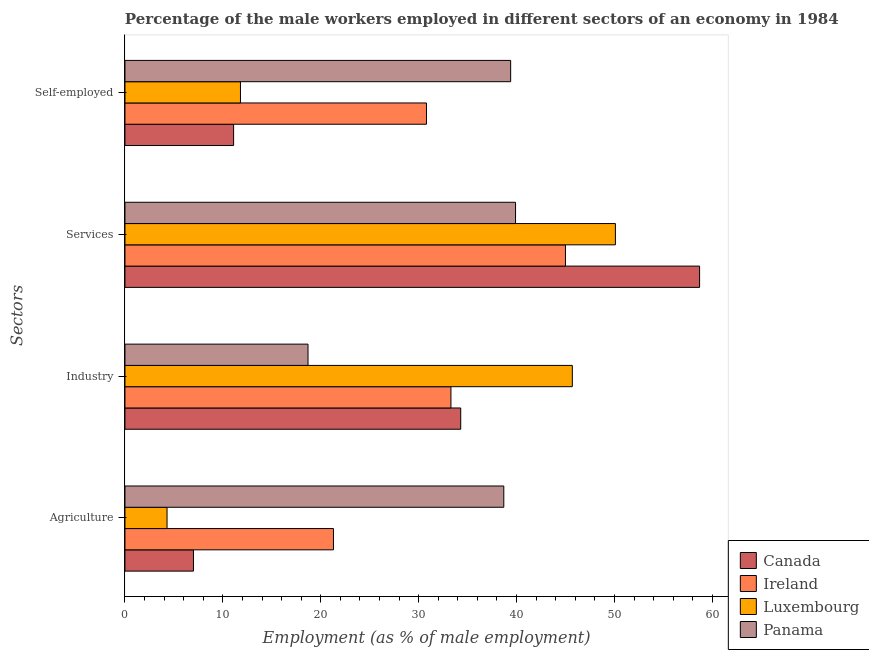How many groups of bars are there?
Give a very brief answer. 4. Are the number of bars per tick equal to the number of legend labels?
Provide a succinct answer. Yes. Are the number of bars on each tick of the Y-axis equal?
Offer a terse response. Yes. How many bars are there on the 4th tick from the top?
Make the answer very short. 4. What is the label of the 2nd group of bars from the top?
Offer a very short reply. Services. What is the percentage of male workers in industry in Ireland?
Your response must be concise. 33.3. Across all countries, what is the maximum percentage of male workers in services?
Ensure brevity in your answer.  58.7. Across all countries, what is the minimum percentage of self employed male workers?
Provide a short and direct response. 11.1. In which country was the percentage of male workers in services maximum?
Provide a short and direct response. Canada. In which country was the percentage of male workers in industry minimum?
Provide a short and direct response. Panama. What is the total percentage of male workers in services in the graph?
Provide a succinct answer. 193.7. What is the difference between the percentage of male workers in services in Luxembourg and that in Canada?
Provide a succinct answer. -8.6. What is the difference between the percentage of male workers in industry in Canada and the percentage of male workers in services in Luxembourg?
Provide a succinct answer. -15.8. What is the average percentage of male workers in services per country?
Offer a very short reply. 48.43. What is the difference between the percentage of male workers in industry and percentage of self employed male workers in Ireland?
Ensure brevity in your answer.  2.5. What is the ratio of the percentage of male workers in services in Canada to that in Panama?
Give a very brief answer. 1.47. Is the percentage of male workers in industry in Canada less than that in Panama?
Your response must be concise. No. Is the difference between the percentage of male workers in industry in Luxembourg and Ireland greater than the difference between the percentage of male workers in agriculture in Luxembourg and Ireland?
Your answer should be compact. Yes. What is the difference between the highest and the second highest percentage of male workers in agriculture?
Ensure brevity in your answer.  17.4. What is the difference between the highest and the lowest percentage of self employed male workers?
Offer a very short reply. 28.3. In how many countries, is the percentage of male workers in industry greater than the average percentage of male workers in industry taken over all countries?
Your answer should be compact. 3. Is the sum of the percentage of male workers in industry in Luxembourg and Canada greater than the maximum percentage of self employed male workers across all countries?
Make the answer very short. Yes. What does the 1st bar from the top in Agriculture represents?
Give a very brief answer. Panama. What does the 4th bar from the bottom in Agriculture represents?
Your answer should be compact. Panama. How many bars are there?
Give a very brief answer. 16. Are all the bars in the graph horizontal?
Provide a short and direct response. Yes. Are the values on the major ticks of X-axis written in scientific E-notation?
Offer a very short reply. No. Does the graph contain grids?
Give a very brief answer. No. Where does the legend appear in the graph?
Offer a very short reply. Bottom right. How many legend labels are there?
Offer a terse response. 4. How are the legend labels stacked?
Provide a short and direct response. Vertical. What is the title of the graph?
Your answer should be compact. Percentage of the male workers employed in different sectors of an economy in 1984. What is the label or title of the X-axis?
Keep it short and to the point. Employment (as % of male employment). What is the label or title of the Y-axis?
Your answer should be compact. Sectors. What is the Employment (as % of male employment) of Ireland in Agriculture?
Make the answer very short. 21.3. What is the Employment (as % of male employment) in Luxembourg in Agriculture?
Your answer should be very brief. 4.3. What is the Employment (as % of male employment) of Panama in Agriculture?
Keep it short and to the point. 38.7. What is the Employment (as % of male employment) of Canada in Industry?
Provide a succinct answer. 34.3. What is the Employment (as % of male employment) in Ireland in Industry?
Give a very brief answer. 33.3. What is the Employment (as % of male employment) of Luxembourg in Industry?
Ensure brevity in your answer.  45.7. What is the Employment (as % of male employment) in Panama in Industry?
Ensure brevity in your answer.  18.7. What is the Employment (as % of male employment) of Canada in Services?
Offer a very short reply. 58.7. What is the Employment (as % of male employment) in Luxembourg in Services?
Make the answer very short. 50.1. What is the Employment (as % of male employment) of Panama in Services?
Make the answer very short. 39.9. What is the Employment (as % of male employment) of Canada in Self-employed?
Your response must be concise. 11.1. What is the Employment (as % of male employment) in Ireland in Self-employed?
Your answer should be compact. 30.8. What is the Employment (as % of male employment) of Luxembourg in Self-employed?
Your answer should be very brief. 11.8. What is the Employment (as % of male employment) of Panama in Self-employed?
Your response must be concise. 39.4. Across all Sectors, what is the maximum Employment (as % of male employment) of Canada?
Offer a very short reply. 58.7. Across all Sectors, what is the maximum Employment (as % of male employment) of Ireland?
Keep it short and to the point. 45. Across all Sectors, what is the maximum Employment (as % of male employment) of Luxembourg?
Offer a very short reply. 50.1. Across all Sectors, what is the maximum Employment (as % of male employment) in Panama?
Your answer should be very brief. 39.9. Across all Sectors, what is the minimum Employment (as % of male employment) in Canada?
Make the answer very short. 7. Across all Sectors, what is the minimum Employment (as % of male employment) in Ireland?
Offer a terse response. 21.3. Across all Sectors, what is the minimum Employment (as % of male employment) of Luxembourg?
Your answer should be compact. 4.3. Across all Sectors, what is the minimum Employment (as % of male employment) in Panama?
Offer a very short reply. 18.7. What is the total Employment (as % of male employment) of Canada in the graph?
Provide a succinct answer. 111.1. What is the total Employment (as % of male employment) in Ireland in the graph?
Ensure brevity in your answer.  130.4. What is the total Employment (as % of male employment) in Luxembourg in the graph?
Your answer should be compact. 111.9. What is the total Employment (as % of male employment) of Panama in the graph?
Ensure brevity in your answer.  136.7. What is the difference between the Employment (as % of male employment) of Canada in Agriculture and that in Industry?
Offer a very short reply. -27.3. What is the difference between the Employment (as % of male employment) of Ireland in Agriculture and that in Industry?
Offer a terse response. -12. What is the difference between the Employment (as % of male employment) of Luxembourg in Agriculture and that in Industry?
Provide a succinct answer. -41.4. What is the difference between the Employment (as % of male employment) in Panama in Agriculture and that in Industry?
Provide a short and direct response. 20. What is the difference between the Employment (as % of male employment) of Canada in Agriculture and that in Services?
Your answer should be very brief. -51.7. What is the difference between the Employment (as % of male employment) of Ireland in Agriculture and that in Services?
Your answer should be very brief. -23.7. What is the difference between the Employment (as % of male employment) in Luxembourg in Agriculture and that in Services?
Your response must be concise. -45.8. What is the difference between the Employment (as % of male employment) in Canada in Agriculture and that in Self-employed?
Provide a short and direct response. -4.1. What is the difference between the Employment (as % of male employment) in Luxembourg in Agriculture and that in Self-employed?
Make the answer very short. -7.5. What is the difference between the Employment (as % of male employment) of Panama in Agriculture and that in Self-employed?
Your response must be concise. -0.7. What is the difference between the Employment (as % of male employment) of Canada in Industry and that in Services?
Provide a succinct answer. -24.4. What is the difference between the Employment (as % of male employment) of Panama in Industry and that in Services?
Provide a short and direct response. -21.2. What is the difference between the Employment (as % of male employment) in Canada in Industry and that in Self-employed?
Offer a terse response. 23.2. What is the difference between the Employment (as % of male employment) in Luxembourg in Industry and that in Self-employed?
Your response must be concise. 33.9. What is the difference between the Employment (as % of male employment) of Panama in Industry and that in Self-employed?
Give a very brief answer. -20.7. What is the difference between the Employment (as % of male employment) of Canada in Services and that in Self-employed?
Your response must be concise. 47.6. What is the difference between the Employment (as % of male employment) in Luxembourg in Services and that in Self-employed?
Make the answer very short. 38.3. What is the difference between the Employment (as % of male employment) in Panama in Services and that in Self-employed?
Provide a succinct answer. 0.5. What is the difference between the Employment (as % of male employment) of Canada in Agriculture and the Employment (as % of male employment) of Ireland in Industry?
Your answer should be very brief. -26.3. What is the difference between the Employment (as % of male employment) in Canada in Agriculture and the Employment (as % of male employment) in Luxembourg in Industry?
Give a very brief answer. -38.7. What is the difference between the Employment (as % of male employment) in Canada in Agriculture and the Employment (as % of male employment) in Panama in Industry?
Ensure brevity in your answer.  -11.7. What is the difference between the Employment (as % of male employment) in Ireland in Agriculture and the Employment (as % of male employment) in Luxembourg in Industry?
Your answer should be very brief. -24.4. What is the difference between the Employment (as % of male employment) of Luxembourg in Agriculture and the Employment (as % of male employment) of Panama in Industry?
Offer a terse response. -14.4. What is the difference between the Employment (as % of male employment) of Canada in Agriculture and the Employment (as % of male employment) of Ireland in Services?
Offer a terse response. -38. What is the difference between the Employment (as % of male employment) of Canada in Agriculture and the Employment (as % of male employment) of Luxembourg in Services?
Offer a terse response. -43.1. What is the difference between the Employment (as % of male employment) in Canada in Agriculture and the Employment (as % of male employment) in Panama in Services?
Give a very brief answer. -32.9. What is the difference between the Employment (as % of male employment) of Ireland in Agriculture and the Employment (as % of male employment) of Luxembourg in Services?
Provide a succinct answer. -28.8. What is the difference between the Employment (as % of male employment) in Ireland in Agriculture and the Employment (as % of male employment) in Panama in Services?
Offer a very short reply. -18.6. What is the difference between the Employment (as % of male employment) of Luxembourg in Agriculture and the Employment (as % of male employment) of Panama in Services?
Offer a very short reply. -35.6. What is the difference between the Employment (as % of male employment) of Canada in Agriculture and the Employment (as % of male employment) of Ireland in Self-employed?
Your response must be concise. -23.8. What is the difference between the Employment (as % of male employment) of Canada in Agriculture and the Employment (as % of male employment) of Panama in Self-employed?
Your answer should be very brief. -32.4. What is the difference between the Employment (as % of male employment) of Ireland in Agriculture and the Employment (as % of male employment) of Luxembourg in Self-employed?
Your response must be concise. 9.5. What is the difference between the Employment (as % of male employment) in Ireland in Agriculture and the Employment (as % of male employment) in Panama in Self-employed?
Your answer should be compact. -18.1. What is the difference between the Employment (as % of male employment) of Luxembourg in Agriculture and the Employment (as % of male employment) of Panama in Self-employed?
Offer a very short reply. -35.1. What is the difference between the Employment (as % of male employment) in Canada in Industry and the Employment (as % of male employment) in Ireland in Services?
Your answer should be very brief. -10.7. What is the difference between the Employment (as % of male employment) of Canada in Industry and the Employment (as % of male employment) of Luxembourg in Services?
Your answer should be very brief. -15.8. What is the difference between the Employment (as % of male employment) of Ireland in Industry and the Employment (as % of male employment) of Luxembourg in Services?
Keep it short and to the point. -16.8. What is the difference between the Employment (as % of male employment) in Canada in Industry and the Employment (as % of male employment) in Ireland in Self-employed?
Make the answer very short. 3.5. What is the difference between the Employment (as % of male employment) in Canada in Industry and the Employment (as % of male employment) in Panama in Self-employed?
Your answer should be compact. -5.1. What is the difference between the Employment (as % of male employment) of Ireland in Industry and the Employment (as % of male employment) of Panama in Self-employed?
Make the answer very short. -6.1. What is the difference between the Employment (as % of male employment) of Luxembourg in Industry and the Employment (as % of male employment) of Panama in Self-employed?
Keep it short and to the point. 6.3. What is the difference between the Employment (as % of male employment) in Canada in Services and the Employment (as % of male employment) in Ireland in Self-employed?
Your answer should be compact. 27.9. What is the difference between the Employment (as % of male employment) in Canada in Services and the Employment (as % of male employment) in Luxembourg in Self-employed?
Keep it short and to the point. 46.9. What is the difference between the Employment (as % of male employment) of Canada in Services and the Employment (as % of male employment) of Panama in Self-employed?
Give a very brief answer. 19.3. What is the difference between the Employment (as % of male employment) of Ireland in Services and the Employment (as % of male employment) of Luxembourg in Self-employed?
Make the answer very short. 33.2. What is the difference between the Employment (as % of male employment) in Ireland in Services and the Employment (as % of male employment) in Panama in Self-employed?
Provide a short and direct response. 5.6. What is the average Employment (as % of male employment) in Canada per Sectors?
Provide a short and direct response. 27.77. What is the average Employment (as % of male employment) of Ireland per Sectors?
Provide a succinct answer. 32.6. What is the average Employment (as % of male employment) in Luxembourg per Sectors?
Your answer should be very brief. 27.98. What is the average Employment (as % of male employment) in Panama per Sectors?
Make the answer very short. 34.17. What is the difference between the Employment (as % of male employment) of Canada and Employment (as % of male employment) of Ireland in Agriculture?
Provide a short and direct response. -14.3. What is the difference between the Employment (as % of male employment) of Canada and Employment (as % of male employment) of Panama in Agriculture?
Offer a terse response. -31.7. What is the difference between the Employment (as % of male employment) of Ireland and Employment (as % of male employment) of Panama in Agriculture?
Your answer should be compact. -17.4. What is the difference between the Employment (as % of male employment) in Luxembourg and Employment (as % of male employment) in Panama in Agriculture?
Give a very brief answer. -34.4. What is the difference between the Employment (as % of male employment) of Canada and Employment (as % of male employment) of Panama in Industry?
Keep it short and to the point. 15.6. What is the difference between the Employment (as % of male employment) in Canada and Employment (as % of male employment) in Luxembourg in Services?
Your answer should be compact. 8.6. What is the difference between the Employment (as % of male employment) of Ireland and Employment (as % of male employment) of Panama in Services?
Give a very brief answer. 5.1. What is the difference between the Employment (as % of male employment) in Luxembourg and Employment (as % of male employment) in Panama in Services?
Ensure brevity in your answer.  10.2. What is the difference between the Employment (as % of male employment) of Canada and Employment (as % of male employment) of Ireland in Self-employed?
Provide a succinct answer. -19.7. What is the difference between the Employment (as % of male employment) of Canada and Employment (as % of male employment) of Luxembourg in Self-employed?
Provide a succinct answer. -0.7. What is the difference between the Employment (as % of male employment) in Canada and Employment (as % of male employment) in Panama in Self-employed?
Make the answer very short. -28.3. What is the difference between the Employment (as % of male employment) in Ireland and Employment (as % of male employment) in Luxembourg in Self-employed?
Provide a succinct answer. 19. What is the difference between the Employment (as % of male employment) in Ireland and Employment (as % of male employment) in Panama in Self-employed?
Your answer should be very brief. -8.6. What is the difference between the Employment (as % of male employment) in Luxembourg and Employment (as % of male employment) in Panama in Self-employed?
Your response must be concise. -27.6. What is the ratio of the Employment (as % of male employment) of Canada in Agriculture to that in Industry?
Ensure brevity in your answer.  0.2. What is the ratio of the Employment (as % of male employment) in Ireland in Agriculture to that in Industry?
Your answer should be very brief. 0.64. What is the ratio of the Employment (as % of male employment) of Luxembourg in Agriculture to that in Industry?
Your answer should be very brief. 0.09. What is the ratio of the Employment (as % of male employment) of Panama in Agriculture to that in Industry?
Make the answer very short. 2.07. What is the ratio of the Employment (as % of male employment) of Canada in Agriculture to that in Services?
Your answer should be very brief. 0.12. What is the ratio of the Employment (as % of male employment) of Ireland in Agriculture to that in Services?
Make the answer very short. 0.47. What is the ratio of the Employment (as % of male employment) of Luxembourg in Agriculture to that in Services?
Make the answer very short. 0.09. What is the ratio of the Employment (as % of male employment) in Panama in Agriculture to that in Services?
Offer a very short reply. 0.97. What is the ratio of the Employment (as % of male employment) in Canada in Agriculture to that in Self-employed?
Give a very brief answer. 0.63. What is the ratio of the Employment (as % of male employment) of Ireland in Agriculture to that in Self-employed?
Offer a very short reply. 0.69. What is the ratio of the Employment (as % of male employment) in Luxembourg in Agriculture to that in Self-employed?
Your answer should be compact. 0.36. What is the ratio of the Employment (as % of male employment) in Panama in Agriculture to that in Self-employed?
Offer a very short reply. 0.98. What is the ratio of the Employment (as % of male employment) in Canada in Industry to that in Services?
Give a very brief answer. 0.58. What is the ratio of the Employment (as % of male employment) of Ireland in Industry to that in Services?
Provide a short and direct response. 0.74. What is the ratio of the Employment (as % of male employment) of Luxembourg in Industry to that in Services?
Offer a very short reply. 0.91. What is the ratio of the Employment (as % of male employment) of Panama in Industry to that in Services?
Your answer should be compact. 0.47. What is the ratio of the Employment (as % of male employment) of Canada in Industry to that in Self-employed?
Make the answer very short. 3.09. What is the ratio of the Employment (as % of male employment) in Ireland in Industry to that in Self-employed?
Make the answer very short. 1.08. What is the ratio of the Employment (as % of male employment) in Luxembourg in Industry to that in Self-employed?
Give a very brief answer. 3.87. What is the ratio of the Employment (as % of male employment) in Panama in Industry to that in Self-employed?
Your answer should be very brief. 0.47. What is the ratio of the Employment (as % of male employment) of Canada in Services to that in Self-employed?
Make the answer very short. 5.29. What is the ratio of the Employment (as % of male employment) in Ireland in Services to that in Self-employed?
Offer a very short reply. 1.46. What is the ratio of the Employment (as % of male employment) in Luxembourg in Services to that in Self-employed?
Offer a terse response. 4.25. What is the ratio of the Employment (as % of male employment) in Panama in Services to that in Self-employed?
Provide a succinct answer. 1.01. What is the difference between the highest and the second highest Employment (as % of male employment) in Canada?
Your answer should be very brief. 24.4. What is the difference between the highest and the second highest Employment (as % of male employment) of Ireland?
Offer a terse response. 11.7. What is the difference between the highest and the lowest Employment (as % of male employment) of Canada?
Offer a very short reply. 51.7. What is the difference between the highest and the lowest Employment (as % of male employment) in Ireland?
Ensure brevity in your answer.  23.7. What is the difference between the highest and the lowest Employment (as % of male employment) in Luxembourg?
Ensure brevity in your answer.  45.8. What is the difference between the highest and the lowest Employment (as % of male employment) of Panama?
Your answer should be very brief. 21.2. 